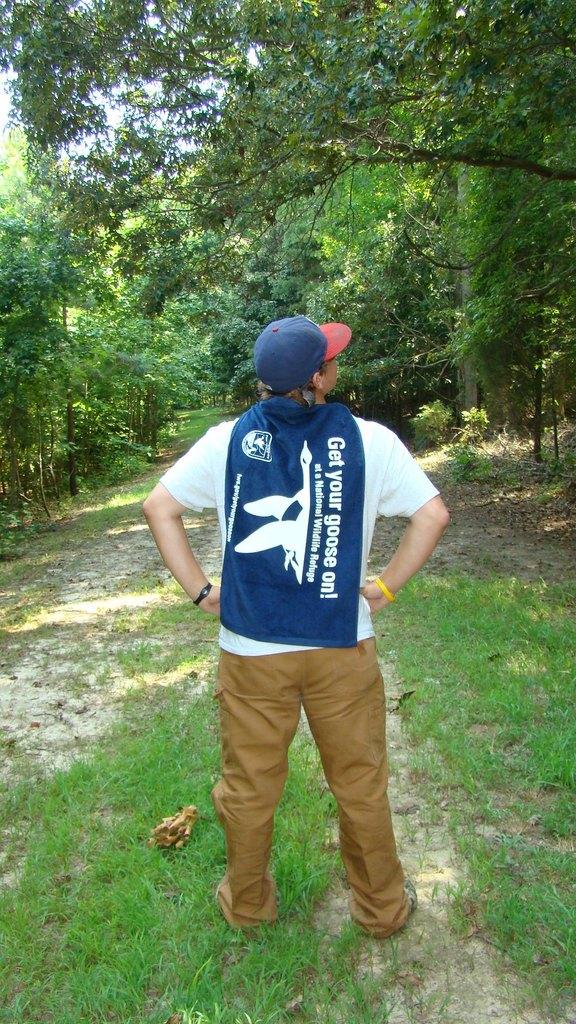What does his cape advertise?
Keep it short and to the point. Get your goose on. What does his cape say?
Provide a short and direct response. Get your goose on. 